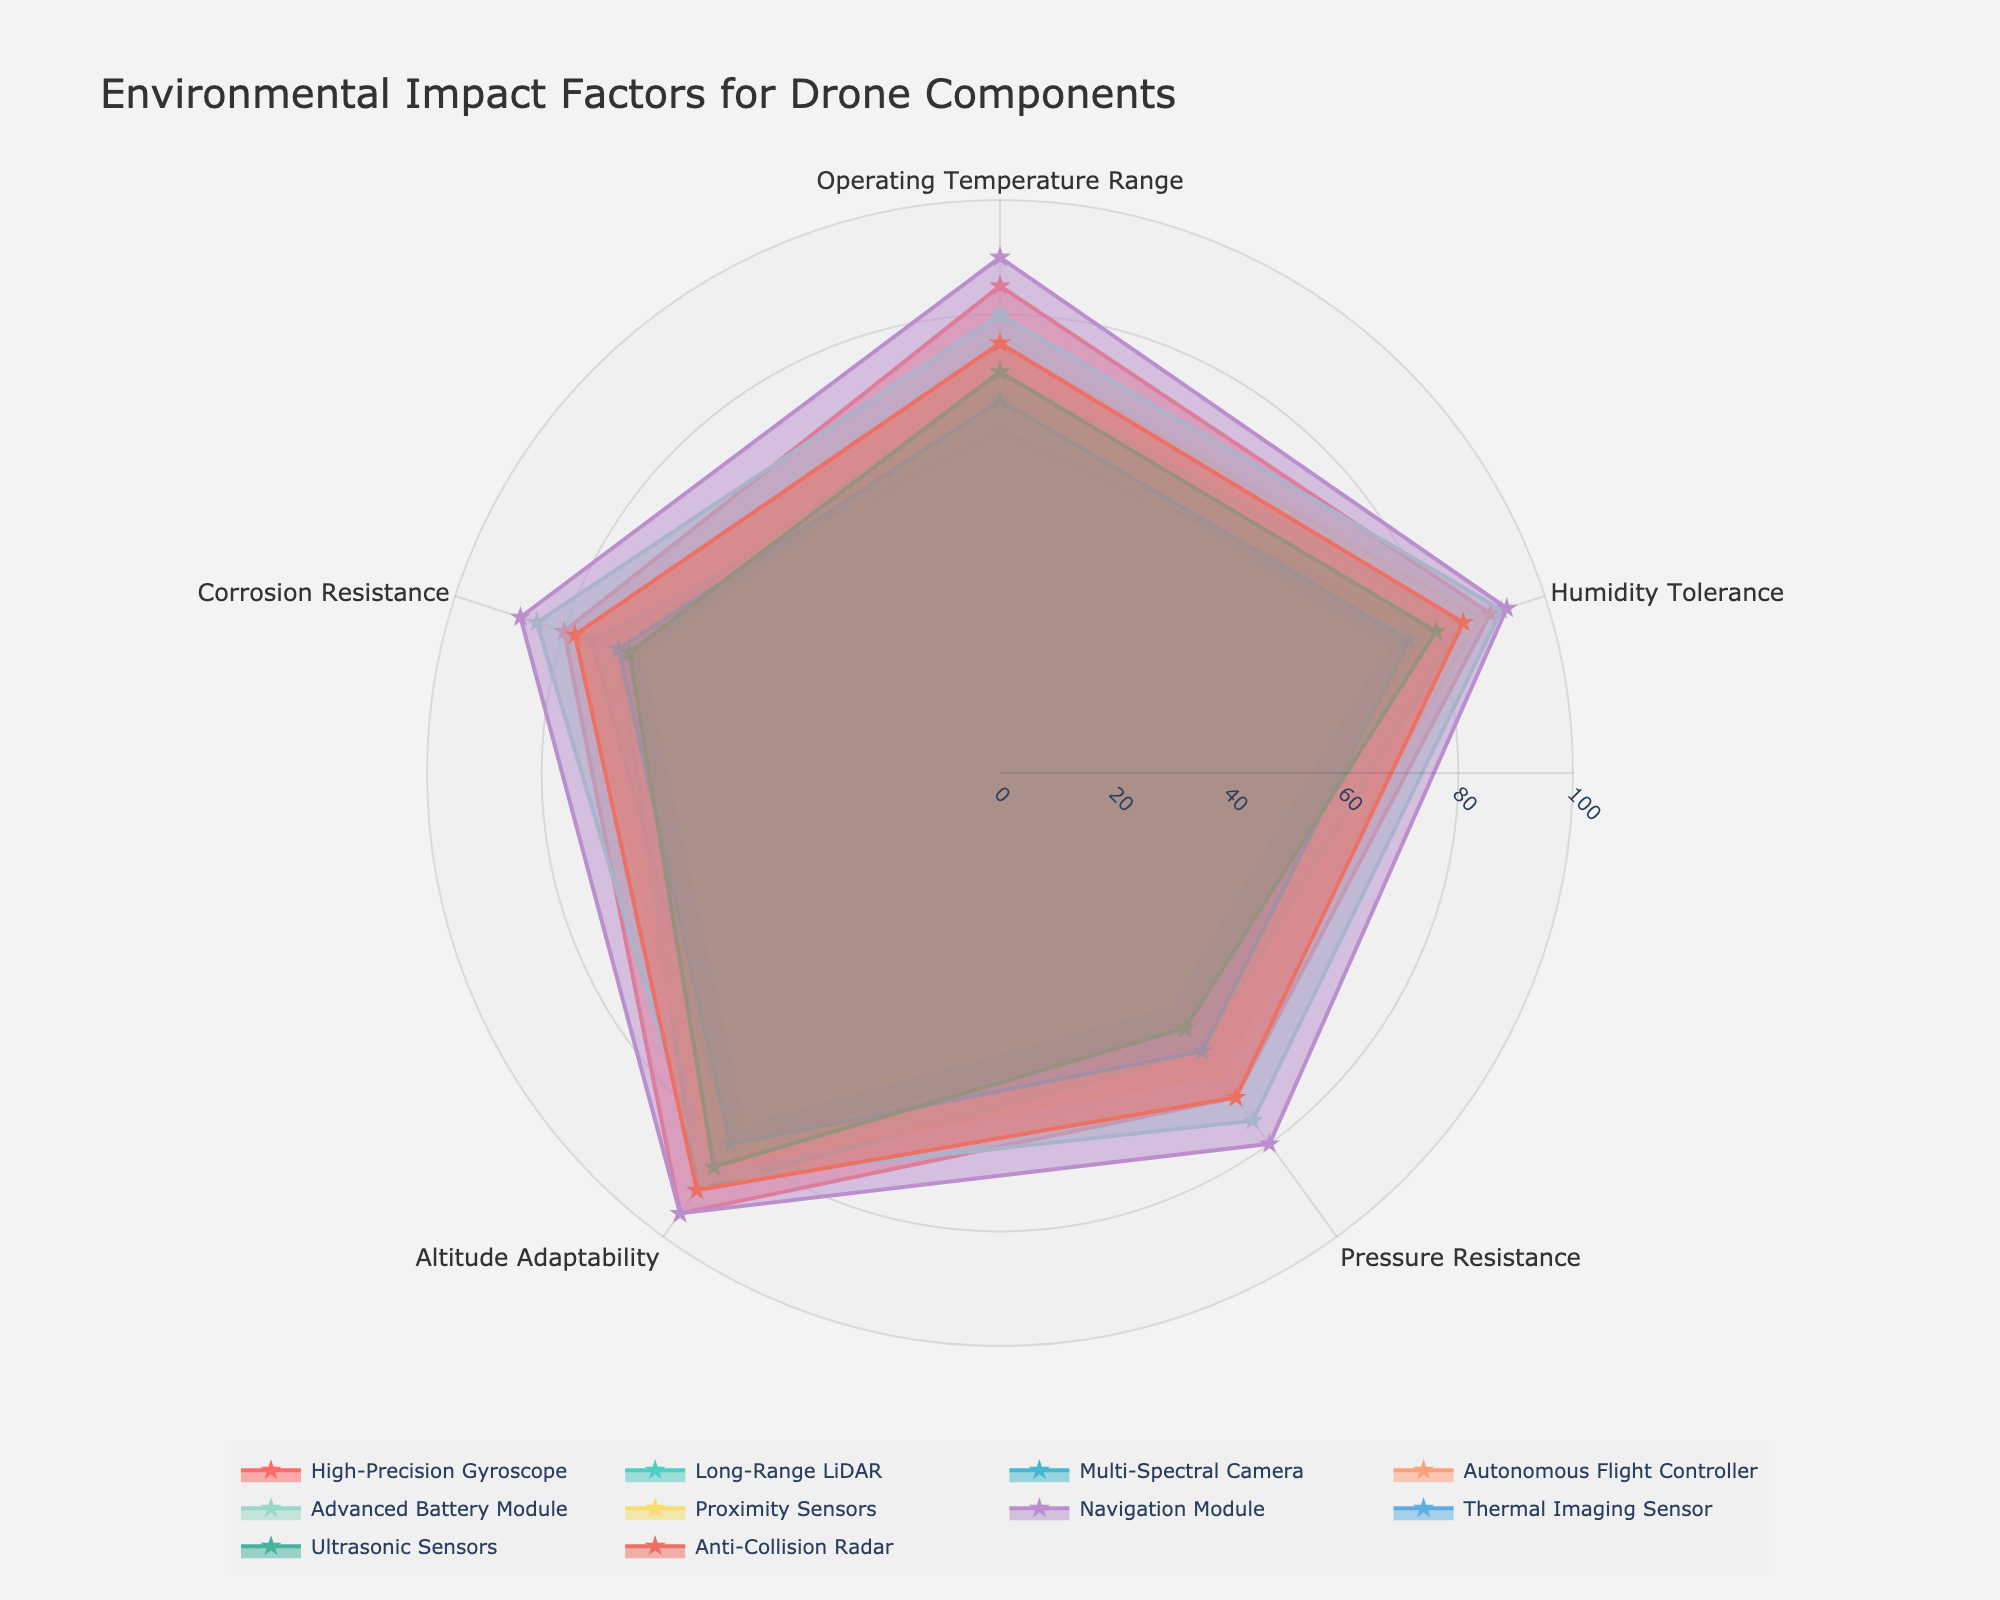What component has the highest value for Corrosion Resistance? The radar chart shows different components and their values for various factors. The Navigation Module has the highest value for Corrosion Resistance visually represented around 88.
Answer: Navigation Module Which component has the lowest value for Humidity Tolerance? By comparing the values for Humidity Tolerance, Proximity Sensors have the lowest value at around 70.
Answer: Proximity Sensors What is the average Pressure Resistance value for all components? Summing up the Pressure Resistance values: (70 + 60 + 55 + 65 + 75 + 50 + 80 + 60 + 55 + 70) = 640. The number of components is 10, so the average is 640/10 = 64.
Answer: 64 Which components have higher Altitude Adaptability than Ultrasonic Sensors? Ultrasonic Sensors have an Altitude Adaptability value of 85. The components with values higher are High-Precision Gyroscope (95), Long-Range LiDAR (90), Advanced Battery Module (88), Navigation Module (95), and Anti-Collision Radar (90).
Answer: High-Precision Gyroscope, Long-Range LiDAR, Advanced Battery Module, Navigation Module, Anti-Collision Radar Compare the Operating Temperature Range of High-Precision Gyroscope and Multi-Spectral Camera. Which one is higher? The chart shows High-Precision Gyroscope with a value of 85 and Multi-Spectral Camera with a value of 60 for Operating Temperature Range. Thus, High-Precision Gyroscope is higher.
Answer: High-Precision Gyroscope Which two components have exactly 75 for Humidity Tolerance, and how close are their values across the other environmental impact factors? Thermal Imaging Sensor and Ultrasonic Sensors both have a Humidity Tolerance of 75. They differ in other factors as follows: Operating Temperature Range (65 vs. 70), Pressure Resistance (60 vs. 55), Altitude Adaptability (80 vs. 85), and Corrosion Resistance (70 vs. 68).
Answer: Thermal Imaging Sensor, Ultrasonic Sensors, close What is the common value shared by multiple components for Altitude Adaptability? The value of 85 is shared by Autonomous Flight Controller and Ultrasonic Sensors for Altitude Adaptability.
Answer: 85 Which component's performance is the closest to the Advanced Battery Module across all factors? By visually summing and comparing the approximate areas under the polygon for each component, the Navigation Module appears closest in performance to the Advanced Battery Module, both showing strengths around high 80s and low 90s.
Answer: Navigation Module Which component covers the smallest area in the radar chart? By estimating the enclosed area, Proximity Sensors occupy the smallest region due to their relatively lower values across all factors.
Answer: Proximity Sensors 